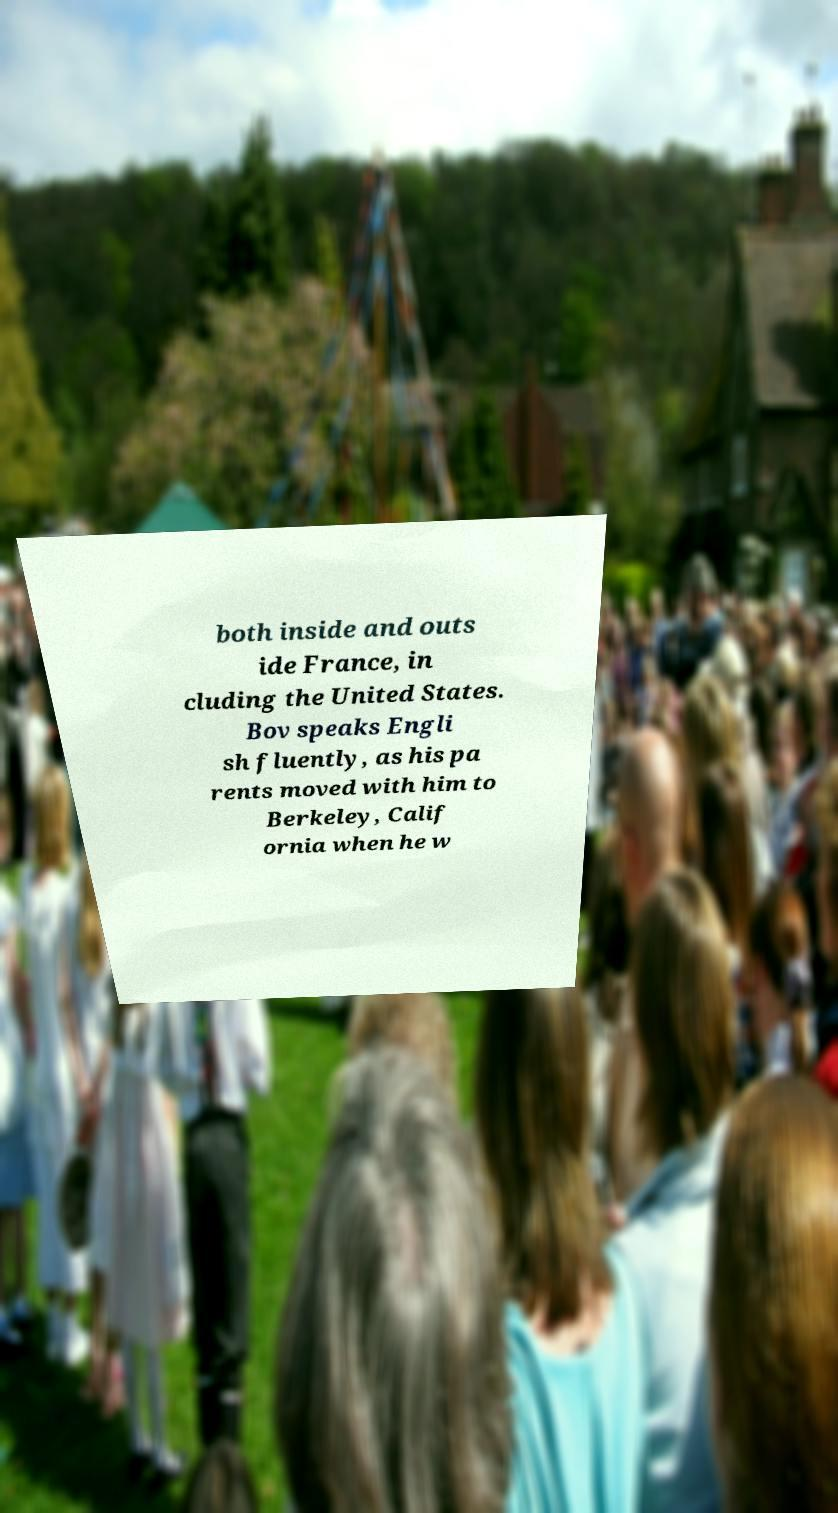I need the written content from this picture converted into text. Can you do that? both inside and outs ide France, in cluding the United States. Bov speaks Engli sh fluently, as his pa rents moved with him to Berkeley, Calif ornia when he w 